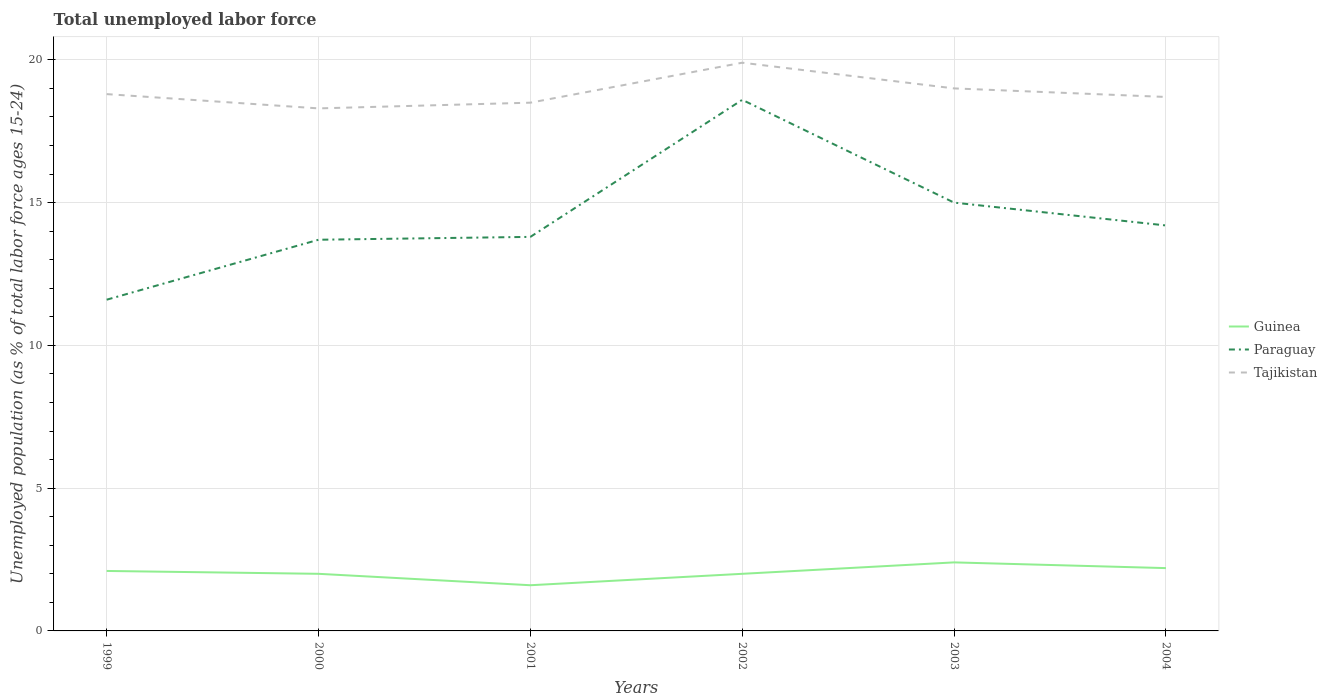Is the number of lines equal to the number of legend labels?
Your answer should be compact. Yes. Across all years, what is the maximum percentage of unemployed population in in Paraguay?
Ensure brevity in your answer.  11.6. What is the total percentage of unemployed population in in Guinea in the graph?
Your response must be concise. 0.2. What is the difference between the highest and the second highest percentage of unemployed population in in Paraguay?
Your answer should be compact. 7. What is the difference between the highest and the lowest percentage of unemployed population in in Tajikistan?
Your answer should be very brief. 2. How many lines are there?
Make the answer very short. 3. Does the graph contain grids?
Your answer should be compact. Yes. How many legend labels are there?
Provide a short and direct response. 3. What is the title of the graph?
Provide a succinct answer. Total unemployed labor force. Does "Paraguay" appear as one of the legend labels in the graph?
Keep it short and to the point. Yes. What is the label or title of the Y-axis?
Your response must be concise. Unemployed population (as % of total labor force ages 15-24). What is the Unemployed population (as % of total labor force ages 15-24) in Guinea in 1999?
Keep it short and to the point. 2.1. What is the Unemployed population (as % of total labor force ages 15-24) in Paraguay in 1999?
Provide a succinct answer. 11.6. What is the Unemployed population (as % of total labor force ages 15-24) in Tajikistan in 1999?
Offer a very short reply. 18.8. What is the Unemployed population (as % of total labor force ages 15-24) of Paraguay in 2000?
Offer a terse response. 13.7. What is the Unemployed population (as % of total labor force ages 15-24) of Tajikistan in 2000?
Give a very brief answer. 18.3. What is the Unemployed population (as % of total labor force ages 15-24) in Guinea in 2001?
Ensure brevity in your answer.  1.6. What is the Unemployed population (as % of total labor force ages 15-24) of Paraguay in 2001?
Give a very brief answer. 13.8. What is the Unemployed population (as % of total labor force ages 15-24) in Guinea in 2002?
Your response must be concise. 2. What is the Unemployed population (as % of total labor force ages 15-24) of Paraguay in 2002?
Give a very brief answer. 18.6. What is the Unemployed population (as % of total labor force ages 15-24) in Tajikistan in 2002?
Provide a short and direct response. 19.9. What is the Unemployed population (as % of total labor force ages 15-24) in Guinea in 2003?
Provide a short and direct response. 2.4. What is the Unemployed population (as % of total labor force ages 15-24) of Paraguay in 2003?
Your answer should be compact. 15. What is the Unemployed population (as % of total labor force ages 15-24) in Guinea in 2004?
Ensure brevity in your answer.  2.2. What is the Unemployed population (as % of total labor force ages 15-24) of Paraguay in 2004?
Make the answer very short. 14.2. What is the Unemployed population (as % of total labor force ages 15-24) of Tajikistan in 2004?
Offer a very short reply. 18.7. Across all years, what is the maximum Unemployed population (as % of total labor force ages 15-24) of Guinea?
Provide a short and direct response. 2.4. Across all years, what is the maximum Unemployed population (as % of total labor force ages 15-24) in Paraguay?
Your answer should be compact. 18.6. Across all years, what is the maximum Unemployed population (as % of total labor force ages 15-24) in Tajikistan?
Offer a very short reply. 19.9. Across all years, what is the minimum Unemployed population (as % of total labor force ages 15-24) of Guinea?
Give a very brief answer. 1.6. Across all years, what is the minimum Unemployed population (as % of total labor force ages 15-24) in Paraguay?
Offer a very short reply. 11.6. Across all years, what is the minimum Unemployed population (as % of total labor force ages 15-24) of Tajikistan?
Give a very brief answer. 18.3. What is the total Unemployed population (as % of total labor force ages 15-24) of Paraguay in the graph?
Your response must be concise. 86.9. What is the total Unemployed population (as % of total labor force ages 15-24) in Tajikistan in the graph?
Your answer should be compact. 113.2. What is the difference between the Unemployed population (as % of total labor force ages 15-24) of Paraguay in 1999 and that in 2000?
Provide a succinct answer. -2.1. What is the difference between the Unemployed population (as % of total labor force ages 15-24) of Tajikistan in 1999 and that in 2000?
Provide a short and direct response. 0.5. What is the difference between the Unemployed population (as % of total labor force ages 15-24) of Paraguay in 1999 and that in 2001?
Offer a terse response. -2.2. What is the difference between the Unemployed population (as % of total labor force ages 15-24) in Tajikistan in 1999 and that in 2002?
Your answer should be compact. -1.1. What is the difference between the Unemployed population (as % of total labor force ages 15-24) in Guinea in 1999 and that in 2004?
Your answer should be compact. -0.1. What is the difference between the Unemployed population (as % of total labor force ages 15-24) of Paraguay in 2000 and that in 2001?
Make the answer very short. -0.1. What is the difference between the Unemployed population (as % of total labor force ages 15-24) of Paraguay in 2000 and that in 2002?
Provide a succinct answer. -4.9. What is the difference between the Unemployed population (as % of total labor force ages 15-24) of Tajikistan in 2000 and that in 2002?
Your response must be concise. -1.6. What is the difference between the Unemployed population (as % of total labor force ages 15-24) in Guinea in 2000 and that in 2003?
Offer a terse response. -0.4. What is the difference between the Unemployed population (as % of total labor force ages 15-24) in Tajikistan in 2000 and that in 2003?
Your answer should be very brief. -0.7. What is the difference between the Unemployed population (as % of total labor force ages 15-24) of Paraguay in 2000 and that in 2004?
Offer a terse response. -0.5. What is the difference between the Unemployed population (as % of total labor force ages 15-24) in Tajikistan in 2000 and that in 2004?
Your response must be concise. -0.4. What is the difference between the Unemployed population (as % of total labor force ages 15-24) of Tajikistan in 2001 and that in 2002?
Provide a short and direct response. -1.4. What is the difference between the Unemployed population (as % of total labor force ages 15-24) of Guinea in 2001 and that in 2003?
Your response must be concise. -0.8. What is the difference between the Unemployed population (as % of total labor force ages 15-24) of Tajikistan in 2001 and that in 2003?
Keep it short and to the point. -0.5. What is the difference between the Unemployed population (as % of total labor force ages 15-24) of Tajikistan in 2001 and that in 2004?
Keep it short and to the point. -0.2. What is the difference between the Unemployed population (as % of total labor force ages 15-24) in Guinea in 2002 and that in 2003?
Provide a short and direct response. -0.4. What is the difference between the Unemployed population (as % of total labor force ages 15-24) in Tajikistan in 2002 and that in 2003?
Your response must be concise. 0.9. What is the difference between the Unemployed population (as % of total labor force ages 15-24) in Guinea in 2002 and that in 2004?
Offer a terse response. -0.2. What is the difference between the Unemployed population (as % of total labor force ages 15-24) of Paraguay in 2002 and that in 2004?
Provide a succinct answer. 4.4. What is the difference between the Unemployed population (as % of total labor force ages 15-24) of Tajikistan in 2002 and that in 2004?
Keep it short and to the point. 1.2. What is the difference between the Unemployed population (as % of total labor force ages 15-24) of Guinea in 2003 and that in 2004?
Give a very brief answer. 0.2. What is the difference between the Unemployed population (as % of total labor force ages 15-24) of Tajikistan in 2003 and that in 2004?
Ensure brevity in your answer.  0.3. What is the difference between the Unemployed population (as % of total labor force ages 15-24) of Guinea in 1999 and the Unemployed population (as % of total labor force ages 15-24) of Paraguay in 2000?
Give a very brief answer. -11.6. What is the difference between the Unemployed population (as % of total labor force ages 15-24) in Guinea in 1999 and the Unemployed population (as % of total labor force ages 15-24) in Tajikistan in 2000?
Your response must be concise. -16.2. What is the difference between the Unemployed population (as % of total labor force ages 15-24) of Paraguay in 1999 and the Unemployed population (as % of total labor force ages 15-24) of Tajikistan in 2000?
Offer a terse response. -6.7. What is the difference between the Unemployed population (as % of total labor force ages 15-24) in Guinea in 1999 and the Unemployed population (as % of total labor force ages 15-24) in Tajikistan in 2001?
Your response must be concise. -16.4. What is the difference between the Unemployed population (as % of total labor force ages 15-24) of Guinea in 1999 and the Unemployed population (as % of total labor force ages 15-24) of Paraguay in 2002?
Offer a terse response. -16.5. What is the difference between the Unemployed population (as % of total labor force ages 15-24) of Guinea in 1999 and the Unemployed population (as % of total labor force ages 15-24) of Tajikistan in 2002?
Provide a succinct answer. -17.8. What is the difference between the Unemployed population (as % of total labor force ages 15-24) in Paraguay in 1999 and the Unemployed population (as % of total labor force ages 15-24) in Tajikistan in 2002?
Provide a succinct answer. -8.3. What is the difference between the Unemployed population (as % of total labor force ages 15-24) in Guinea in 1999 and the Unemployed population (as % of total labor force ages 15-24) in Tajikistan in 2003?
Offer a terse response. -16.9. What is the difference between the Unemployed population (as % of total labor force ages 15-24) of Paraguay in 1999 and the Unemployed population (as % of total labor force ages 15-24) of Tajikistan in 2003?
Provide a succinct answer. -7.4. What is the difference between the Unemployed population (as % of total labor force ages 15-24) of Guinea in 1999 and the Unemployed population (as % of total labor force ages 15-24) of Paraguay in 2004?
Keep it short and to the point. -12.1. What is the difference between the Unemployed population (as % of total labor force ages 15-24) of Guinea in 1999 and the Unemployed population (as % of total labor force ages 15-24) of Tajikistan in 2004?
Make the answer very short. -16.6. What is the difference between the Unemployed population (as % of total labor force ages 15-24) of Paraguay in 1999 and the Unemployed population (as % of total labor force ages 15-24) of Tajikistan in 2004?
Offer a very short reply. -7.1. What is the difference between the Unemployed population (as % of total labor force ages 15-24) of Guinea in 2000 and the Unemployed population (as % of total labor force ages 15-24) of Tajikistan in 2001?
Your response must be concise. -16.5. What is the difference between the Unemployed population (as % of total labor force ages 15-24) in Guinea in 2000 and the Unemployed population (as % of total labor force ages 15-24) in Paraguay in 2002?
Provide a short and direct response. -16.6. What is the difference between the Unemployed population (as % of total labor force ages 15-24) in Guinea in 2000 and the Unemployed population (as % of total labor force ages 15-24) in Tajikistan in 2002?
Your response must be concise. -17.9. What is the difference between the Unemployed population (as % of total labor force ages 15-24) of Guinea in 2000 and the Unemployed population (as % of total labor force ages 15-24) of Paraguay in 2004?
Offer a very short reply. -12.2. What is the difference between the Unemployed population (as % of total labor force ages 15-24) in Guinea in 2000 and the Unemployed population (as % of total labor force ages 15-24) in Tajikistan in 2004?
Make the answer very short. -16.7. What is the difference between the Unemployed population (as % of total labor force ages 15-24) of Paraguay in 2000 and the Unemployed population (as % of total labor force ages 15-24) of Tajikistan in 2004?
Make the answer very short. -5. What is the difference between the Unemployed population (as % of total labor force ages 15-24) of Guinea in 2001 and the Unemployed population (as % of total labor force ages 15-24) of Paraguay in 2002?
Your answer should be compact. -17. What is the difference between the Unemployed population (as % of total labor force ages 15-24) in Guinea in 2001 and the Unemployed population (as % of total labor force ages 15-24) in Tajikistan in 2002?
Your response must be concise. -18.3. What is the difference between the Unemployed population (as % of total labor force ages 15-24) of Guinea in 2001 and the Unemployed population (as % of total labor force ages 15-24) of Paraguay in 2003?
Keep it short and to the point. -13.4. What is the difference between the Unemployed population (as % of total labor force ages 15-24) of Guinea in 2001 and the Unemployed population (as % of total labor force ages 15-24) of Tajikistan in 2003?
Your answer should be compact. -17.4. What is the difference between the Unemployed population (as % of total labor force ages 15-24) of Guinea in 2001 and the Unemployed population (as % of total labor force ages 15-24) of Paraguay in 2004?
Offer a very short reply. -12.6. What is the difference between the Unemployed population (as % of total labor force ages 15-24) in Guinea in 2001 and the Unemployed population (as % of total labor force ages 15-24) in Tajikistan in 2004?
Offer a terse response. -17.1. What is the difference between the Unemployed population (as % of total labor force ages 15-24) in Paraguay in 2001 and the Unemployed population (as % of total labor force ages 15-24) in Tajikistan in 2004?
Make the answer very short. -4.9. What is the difference between the Unemployed population (as % of total labor force ages 15-24) of Guinea in 2002 and the Unemployed population (as % of total labor force ages 15-24) of Tajikistan in 2004?
Make the answer very short. -16.7. What is the difference between the Unemployed population (as % of total labor force ages 15-24) of Guinea in 2003 and the Unemployed population (as % of total labor force ages 15-24) of Tajikistan in 2004?
Your response must be concise. -16.3. What is the difference between the Unemployed population (as % of total labor force ages 15-24) in Paraguay in 2003 and the Unemployed population (as % of total labor force ages 15-24) in Tajikistan in 2004?
Provide a succinct answer. -3.7. What is the average Unemployed population (as % of total labor force ages 15-24) in Guinea per year?
Make the answer very short. 2.05. What is the average Unemployed population (as % of total labor force ages 15-24) of Paraguay per year?
Your answer should be compact. 14.48. What is the average Unemployed population (as % of total labor force ages 15-24) in Tajikistan per year?
Your response must be concise. 18.87. In the year 1999, what is the difference between the Unemployed population (as % of total labor force ages 15-24) of Guinea and Unemployed population (as % of total labor force ages 15-24) of Paraguay?
Your answer should be very brief. -9.5. In the year 1999, what is the difference between the Unemployed population (as % of total labor force ages 15-24) of Guinea and Unemployed population (as % of total labor force ages 15-24) of Tajikistan?
Give a very brief answer. -16.7. In the year 2000, what is the difference between the Unemployed population (as % of total labor force ages 15-24) of Guinea and Unemployed population (as % of total labor force ages 15-24) of Paraguay?
Keep it short and to the point. -11.7. In the year 2000, what is the difference between the Unemployed population (as % of total labor force ages 15-24) in Guinea and Unemployed population (as % of total labor force ages 15-24) in Tajikistan?
Provide a short and direct response. -16.3. In the year 2000, what is the difference between the Unemployed population (as % of total labor force ages 15-24) of Paraguay and Unemployed population (as % of total labor force ages 15-24) of Tajikistan?
Provide a succinct answer. -4.6. In the year 2001, what is the difference between the Unemployed population (as % of total labor force ages 15-24) of Guinea and Unemployed population (as % of total labor force ages 15-24) of Paraguay?
Keep it short and to the point. -12.2. In the year 2001, what is the difference between the Unemployed population (as % of total labor force ages 15-24) in Guinea and Unemployed population (as % of total labor force ages 15-24) in Tajikistan?
Offer a very short reply. -16.9. In the year 2001, what is the difference between the Unemployed population (as % of total labor force ages 15-24) of Paraguay and Unemployed population (as % of total labor force ages 15-24) of Tajikistan?
Give a very brief answer. -4.7. In the year 2002, what is the difference between the Unemployed population (as % of total labor force ages 15-24) of Guinea and Unemployed population (as % of total labor force ages 15-24) of Paraguay?
Give a very brief answer. -16.6. In the year 2002, what is the difference between the Unemployed population (as % of total labor force ages 15-24) in Guinea and Unemployed population (as % of total labor force ages 15-24) in Tajikistan?
Keep it short and to the point. -17.9. In the year 2003, what is the difference between the Unemployed population (as % of total labor force ages 15-24) in Guinea and Unemployed population (as % of total labor force ages 15-24) in Tajikistan?
Offer a very short reply. -16.6. In the year 2003, what is the difference between the Unemployed population (as % of total labor force ages 15-24) in Paraguay and Unemployed population (as % of total labor force ages 15-24) in Tajikistan?
Provide a short and direct response. -4. In the year 2004, what is the difference between the Unemployed population (as % of total labor force ages 15-24) of Guinea and Unemployed population (as % of total labor force ages 15-24) of Tajikistan?
Your response must be concise. -16.5. What is the ratio of the Unemployed population (as % of total labor force ages 15-24) in Guinea in 1999 to that in 2000?
Make the answer very short. 1.05. What is the ratio of the Unemployed population (as % of total labor force ages 15-24) of Paraguay in 1999 to that in 2000?
Offer a terse response. 0.85. What is the ratio of the Unemployed population (as % of total labor force ages 15-24) in Tajikistan in 1999 to that in 2000?
Your response must be concise. 1.03. What is the ratio of the Unemployed population (as % of total labor force ages 15-24) of Guinea in 1999 to that in 2001?
Your answer should be very brief. 1.31. What is the ratio of the Unemployed population (as % of total labor force ages 15-24) in Paraguay in 1999 to that in 2001?
Make the answer very short. 0.84. What is the ratio of the Unemployed population (as % of total labor force ages 15-24) in Tajikistan in 1999 to that in 2001?
Ensure brevity in your answer.  1.02. What is the ratio of the Unemployed population (as % of total labor force ages 15-24) of Paraguay in 1999 to that in 2002?
Provide a succinct answer. 0.62. What is the ratio of the Unemployed population (as % of total labor force ages 15-24) of Tajikistan in 1999 to that in 2002?
Provide a short and direct response. 0.94. What is the ratio of the Unemployed population (as % of total labor force ages 15-24) in Guinea in 1999 to that in 2003?
Provide a succinct answer. 0.88. What is the ratio of the Unemployed population (as % of total labor force ages 15-24) of Paraguay in 1999 to that in 2003?
Your answer should be compact. 0.77. What is the ratio of the Unemployed population (as % of total labor force ages 15-24) in Guinea in 1999 to that in 2004?
Ensure brevity in your answer.  0.95. What is the ratio of the Unemployed population (as % of total labor force ages 15-24) of Paraguay in 1999 to that in 2004?
Ensure brevity in your answer.  0.82. What is the ratio of the Unemployed population (as % of total labor force ages 15-24) in Tajikistan in 1999 to that in 2004?
Offer a very short reply. 1.01. What is the ratio of the Unemployed population (as % of total labor force ages 15-24) of Tajikistan in 2000 to that in 2001?
Make the answer very short. 0.99. What is the ratio of the Unemployed population (as % of total labor force ages 15-24) of Guinea in 2000 to that in 2002?
Offer a very short reply. 1. What is the ratio of the Unemployed population (as % of total labor force ages 15-24) of Paraguay in 2000 to that in 2002?
Offer a terse response. 0.74. What is the ratio of the Unemployed population (as % of total labor force ages 15-24) in Tajikistan in 2000 to that in 2002?
Ensure brevity in your answer.  0.92. What is the ratio of the Unemployed population (as % of total labor force ages 15-24) in Paraguay in 2000 to that in 2003?
Keep it short and to the point. 0.91. What is the ratio of the Unemployed population (as % of total labor force ages 15-24) of Tajikistan in 2000 to that in 2003?
Your response must be concise. 0.96. What is the ratio of the Unemployed population (as % of total labor force ages 15-24) in Paraguay in 2000 to that in 2004?
Your answer should be compact. 0.96. What is the ratio of the Unemployed population (as % of total labor force ages 15-24) of Tajikistan in 2000 to that in 2004?
Provide a short and direct response. 0.98. What is the ratio of the Unemployed population (as % of total labor force ages 15-24) in Paraguay in 2001 to that in 2002?
Keep it short and to the point. 0.74. What is the ratio of the Unemployed population (as % of total labor force ages 15-24) in Tajikistan in 2001 to that in 2002?
Your answer should be very brief. 0.93. What is the ratio of the Unemployed population (as % of total labor force ages 15-24) in Tajikistan in 2001 to that in 2003?
Give a very brief answer. 0.97. What is the ratio of the Unemployed population (as % of total labor force ages 15-24) in Guinea in 2001 to that in 2004?
Ensure brevity in your answer.  0.73. What is the ratio of the Unemployed population (as % of total labor force ages 15-24) in Paraguay in 2001 to that in 2004?
Ensure brevity in your answer.  0.97. What is the ratio of the Unemployed population (as % of total labor force ages 15-24) of Tajikistan in 2001 to that in 2004?
Offer a terse response. 0.99. What is the ratio of the Unemployed population (as % of total labor force ages 15-24) in Guinea in 2002 to that in 2003?
Provide a succinct answer. 0.83. What is the ratio of the Unemployed population (as % of total labor force ages 15-24) in Paraguay in 2002 to that in 2003?
Provide a short and direct response. 1.24. What is the ratio of the Unemployed population (as % of total labor force ages 15-24) of Tajikistan in 2002 to that in 2003?
Your response must be concise. 1.05. What is the ratio of the Unemployed population (as % of total labor force ages 15-24) in Paraguay in 2002 to that in 2004?
Keep it short and to the point. 1.31. What is the ratio of the Unemployed population (as % of total labor force ages 15-24) in Tajikistan in 2002 to that in 2004?
Offer a very short reply. 1.06. What is the ratio of the Unemployed population (as % of total labor force ages 15-24) in Guinea in 2003 to that in 2004?
Your answer should be compact. 1.09. What is the ratio of the Unemployed population (as % of total labor force ages 15-24) of Paraguay in 2003 to that in 2004?
Make the answer very short. 1.06. What is the difference between the highest and the second highest Unemployed population (as % of total labor force ages 15-24) in Tajikistan?
Offer a terse response. 0.9. What is the difference between the highest and the lowest Unemployed population (as % of total labor force ages 15-24) of Guinea?
Provide a short and direct response. 0.8. What is the difference between the highest and the lowest Unemployed population (as % of total labor force ages 15-24) in Paraguay?
Offer a terse response. 7. What is the difference between the highest and the lowest Unemployed population (as % of total labor force ages 15-24) in Tajikistan?
Offer a terse response. 1.6. 